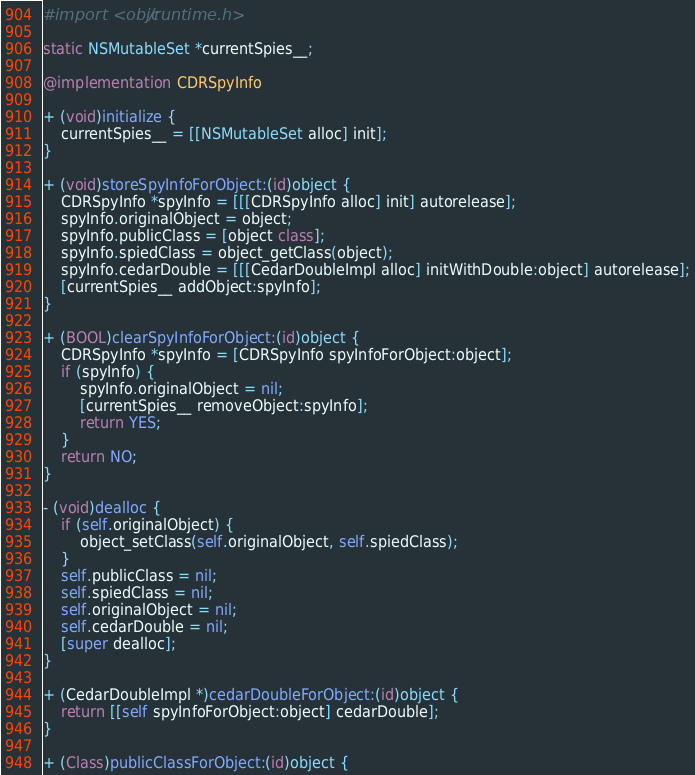Convert code to text. <code><loc_0><loc_0><loc_500><loc_500><_ObjectiveC_>#import <objc/runtime.h>

static NSMutableSet *currentSpies__;

@implementation CDRSpyInfo

+ (void)initialize {
    currentSpies__ = [[NSMutableSet alloc] init];
}

+ (void)storeSpyInfoForObject:(id)object {
    CDRSpyInfo *spyInfo = [[[CDRSpyInfo alloc] init] autorelease];
    spyInfo.originalObject = object;
    spyInfo.publicClass = [object class];
    spyInfo.spiedClass = object_getClass(object);
    spyInfo.cedarDouble = [[[CedarDoubleImpl alloc] initWithDouble:object] autorelease];
    [currentSpies__ addObject:spyInfo];
}

+ (BOOL)clearSpyInfoForObject:(id)object {
    CDRSpyInfo *spyInfo = [CDRSpyInfo spyInfoForObject:object];
    if (spyInfo) {
        spyInfo.originalObject = nil;
        [currentSpies__ removeObject:spyInfo];
        return YES;
    }
    return NO;
}

- (void)dealloc {
    if (self.originalObject) {
        object_setClass(self.originalObject, self.spiedClass);
    }
    self.publicClass = nil;
    self.spiedClass = nil;
    self.originalObject = nil;
    self.cedarDouble = nil;
    [super dealloc];
}

+ (CedarDoubleImpl *)cedarDoubleForObject:(id)object {
    return [[self spyInfoForObject:object] cedarDouble];
}

+ (Class)publicClassForObject:(id)object {</code> 